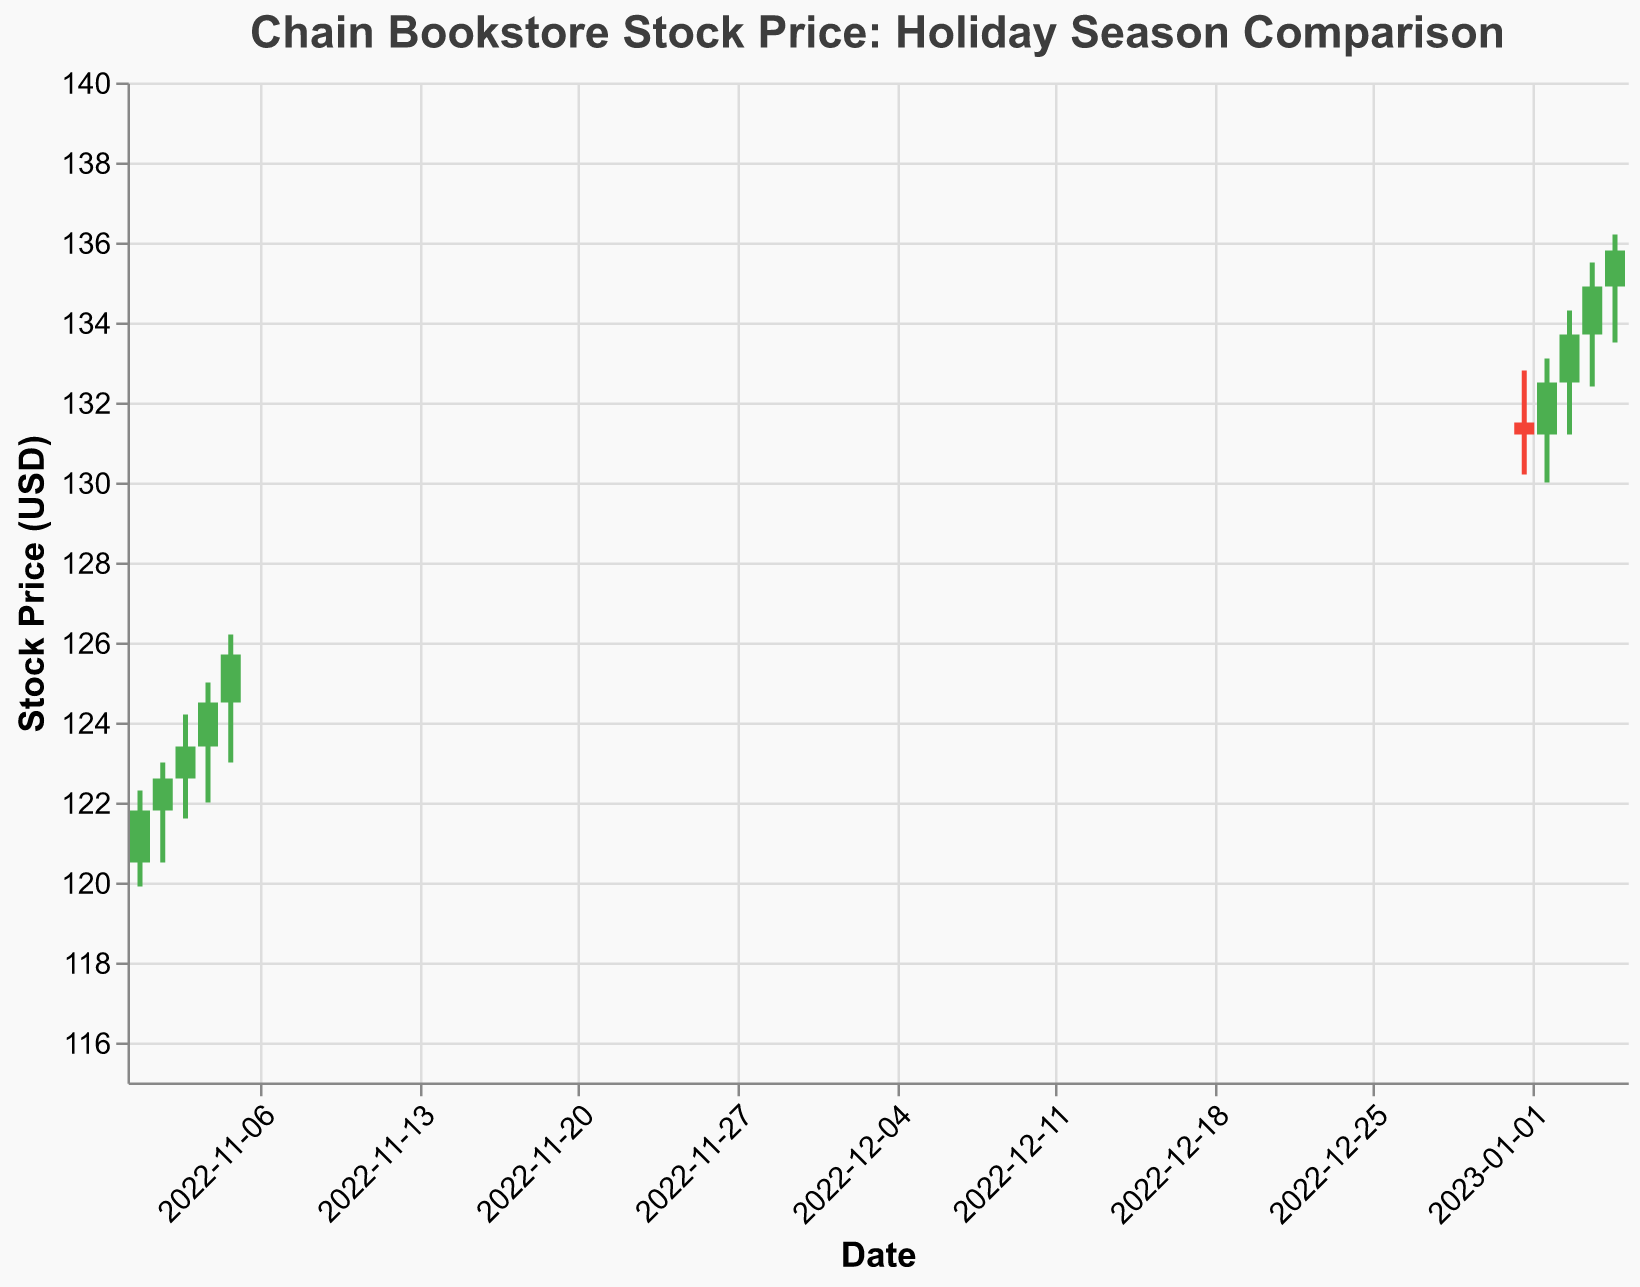What is the title of the plot? The title of the plot is shown at the top and reads "Chain Bookstore Stock Price: Holiday Season Comparison".
Answer: Chain Bookstore Stock Price: Holiday Season Comparison How many data points are there in January 2023? Look at the x-axis for dates in January 2023 and count the data points. There are 5 data points for the dates 2023-01-01 through 2023-01-05.
Answer: 5 What color represents days when the stock closed higher than it opened? In the plot, a certain color is used to indicate when the stock price closes higher than it opened. These days are represented in green.
Answer: Green What is the highest stock price recorded in the dataset? To find the highest stock price, look at the highest points in the figure. The highest price is 136.20 on 2023-01-05.
Answer: 136.20 What is the closing stock price on 2022-11-03? Find the data point for 2022-11-03 along the x-axis and look at the closing price value. The closing price on this date is 123.40.
Answer: 123.40 What is the average closing price for the dates in November 2022? Add the closing prices for November 2022 and divide by the number of dates:
(121.80 + 122.60 + 123.40 + 124.50 + 125.70) / 5 = 123.60
Answer: 123.60 How does the stock price generally trend from 2022-11-01 to 2022-11-05? To determine the trend, observe the sequential changes in the closing stock price over the specified dates. The stock price shows a consistent upward trend.
Answer: Upward Which date had the highest trading volume? Compare the trading volume (Volume) across all given dates and identify the highest one. The highest volume was on 2023-01-01 with 4500.
Answer: 2023-01-01 Was there any day in January 2023 when the stock closed lower than it opened? Look for any red bars in January 2023, which indicate that the stock closed lower than it opened. None of the dates in January 2023 have red bars.
Answer: No What is the difference between the highest and the lowest closing prices in January 2023? Identify the highest and lowest closing prices in January 2023: 135.80 (highest on 2023-01-05) and 131.20 (lowest on 2023-01-01). The difference is 135.80 - 131.20 = 4.60
Answer: 4.60 